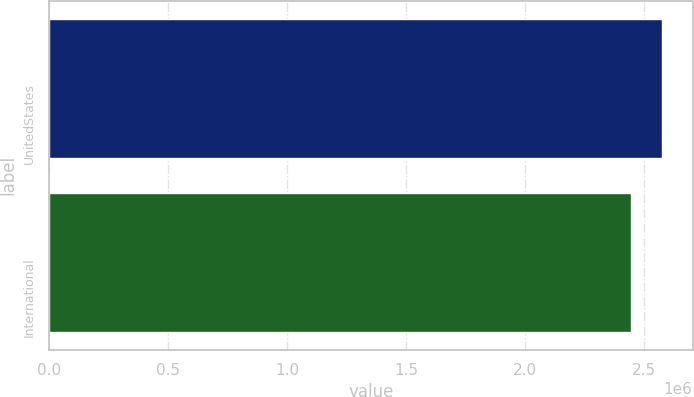Convert chart. <chart><loc_0><loc_0><loc_500><loc_500><bar_chart><fcel>UnitedStates<fcel>International<nl><fcel>2.5757e+06<fcel>2.44413e+06<nl></chart> 